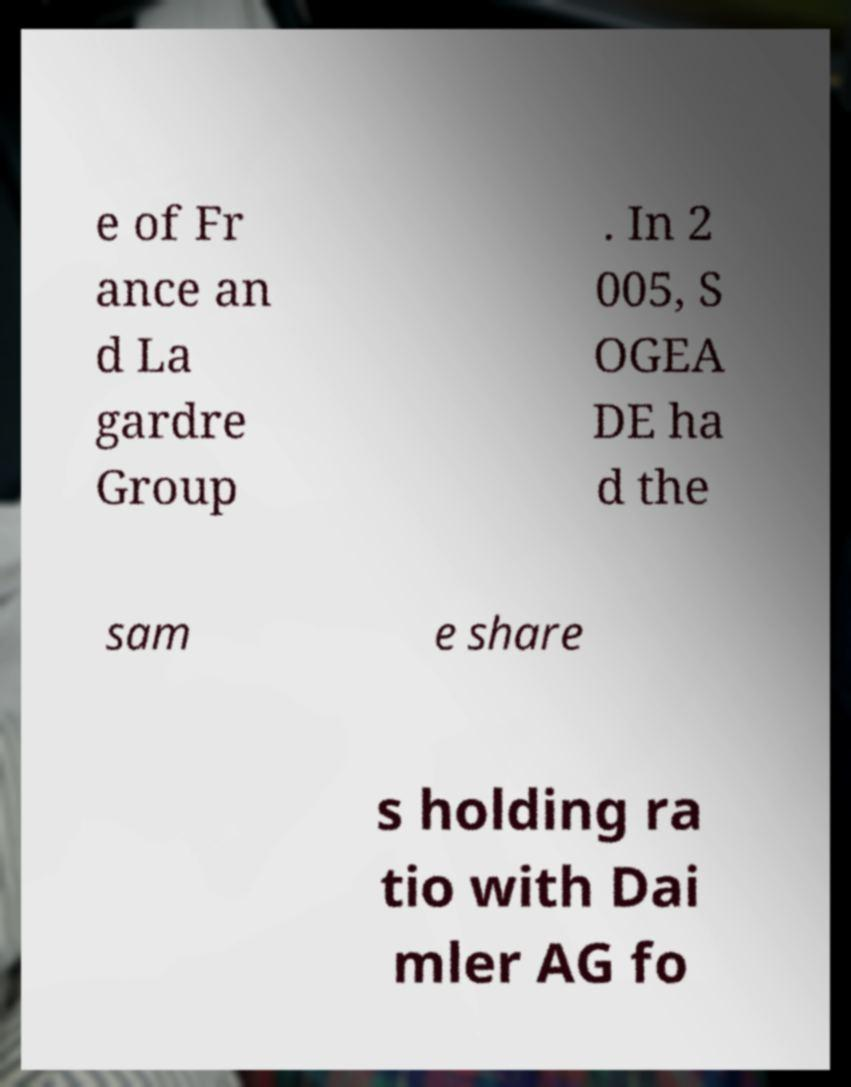What messages or text are displayed in this image? I need them in a readable, typed format. e of Fr ance an d La gardre Group . In 2 005, S OGEA DE ha d the sam e share s holding ra tio with Dai mler AG fo 